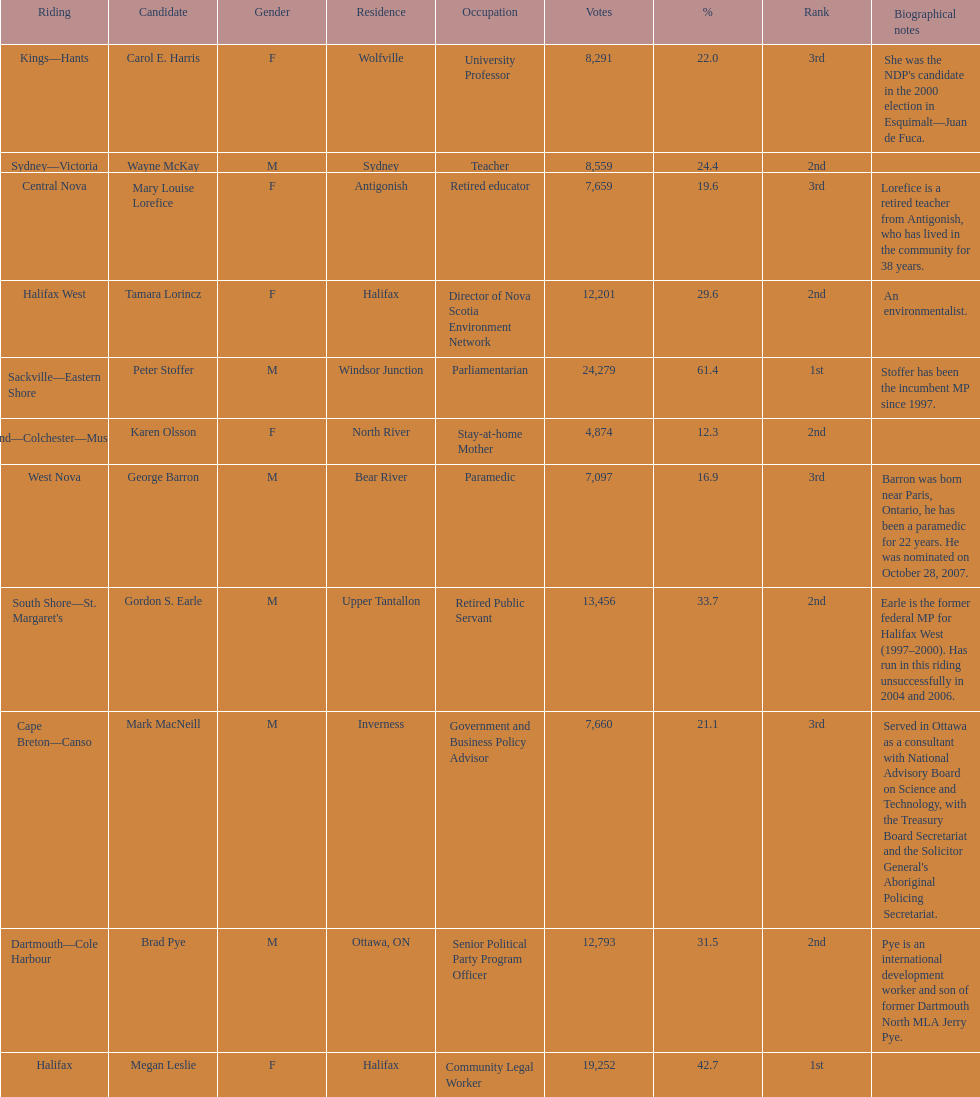Would you be able to parse every entry in this table? {'header': ['Riding', 'Candidate', 'Gender', 'Residence', 'Occupation', 'Votes', '%', 'Rank', 'Biographical notes'], 'rows': [['Kings—Hants', 'Carol E. Harris', 'F', 'Wolfville', 'University Professor', '8,291', '22.0', '3rd', "She was the NDP's candidate in the 2000 election in Esquimalt—Juan de Fuca."], ['Sydney—Victoria', 'Wayne McKay', 'M', 'Sydney', 'Teacher', '8,559', '24.4', '2nd', ''], ['Central Nova', 'Mary Louise Lorefice', 'F', 'Antigonish', 'Retired educator', '7,659', '19.6', '3rd', 'Lorefice is a retired teacher from Antigonish, who has lived in the community for 38 years.'], ['Halifax West', 'Tamara Lorincz', 'F', 'Halifax', 'Director of Nova Scotia Environment Network', '12,201', '29.6', '2nd', 'An environmentalist.'], ['Sackville—Eastern Shore', 'Peter Stoffer', 'M', 'Windsor Junction', 'Parliamentarian', '24,279', '61.4', '1st', 'Stoffer has been the incumbent MP since 1997.'], ['Cumberland—Colchester—Musquodoboit Valley', 'Karen Olsson', 'F', 'North River', 'Stay-at-home Mother', '4,874', '12.3', '2nd', ''], ['West Nova', 'George Barron', 'M', 'Bear River', 'Paramedic', '7,097', '16.9', '3rd', 'Barron was born near Paris, Ontario, he has been a paramedic for 22 years. He was nominated on October 28, 2007.'], ["South Shore—St. Margaret's", 'Gordon S. Earle', 'M', 'Upper Tantallon', 'Retired Public Servant', '13,456', '33.7', '2nd', 'Earle is the former federal MP for Halifax West (1997–2000). Has run in this riding unsuccessfully in 2004 and 2006.'], ['Cape Breton—Canso', 'Mark MacNeill', 'M', 'Inverness', 'Government and Business Policy Advisor', '7,660', '21.1', '3rd', "Served in Ottawa as a consultant with National Advisory Board on Science and Technology, with the Treasury Board Secretariat and the Solicitor General's Aboriginal Policing Secretariat."], ['Dartmouth—Cole Harbour', 'Brad Pye', 'M', 'Ottawa, ON', 'Senior Political Party Program Officer', '12,793', '31.5', '2nd', 'Pye is an international development worker and son of former Dartmouth North MLA Jerry Pye.'], ['Halifax', 'Megan Leslie', 'F', 'Halifax', 'Community Legal Worker', '19,252', '42.7', '1st', '']]} Tell me the total number of votes the female candidates got. 52,277. 